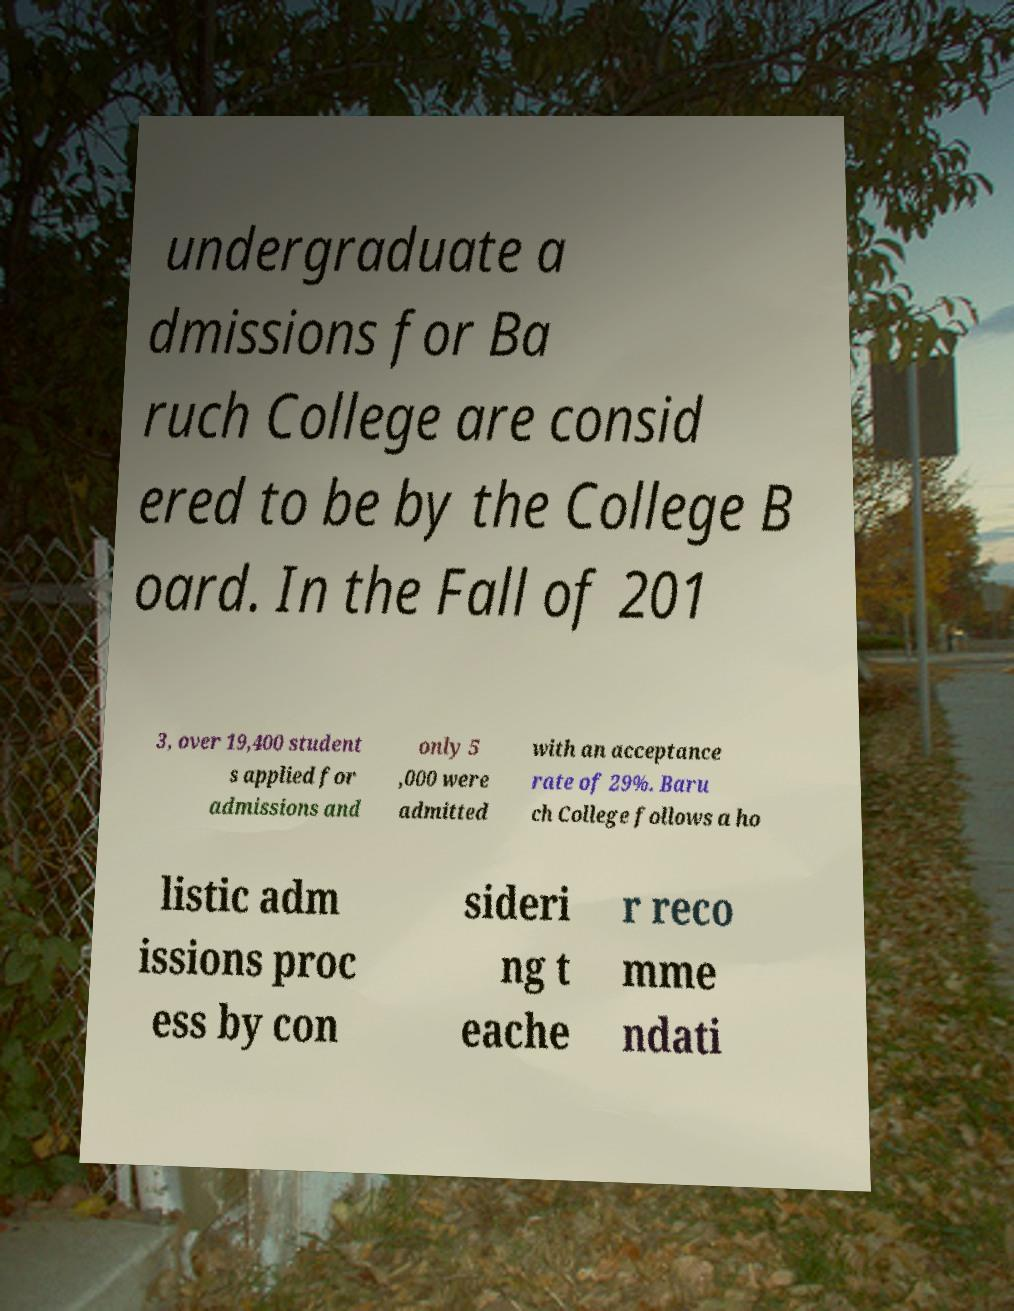Could you extract and type out the text from this image? undergraduate a dmissions for Ba ruch College are consid ered to be by the College B oard. In the Fall of 201 3, over 19,400 student s applied for admissions and only 5 ,000 were admitted with an acceptance rate of 29%. Baru ch College follows a ho listic adm issions proc ess by con sideri ng t eache r reco mme ndati 